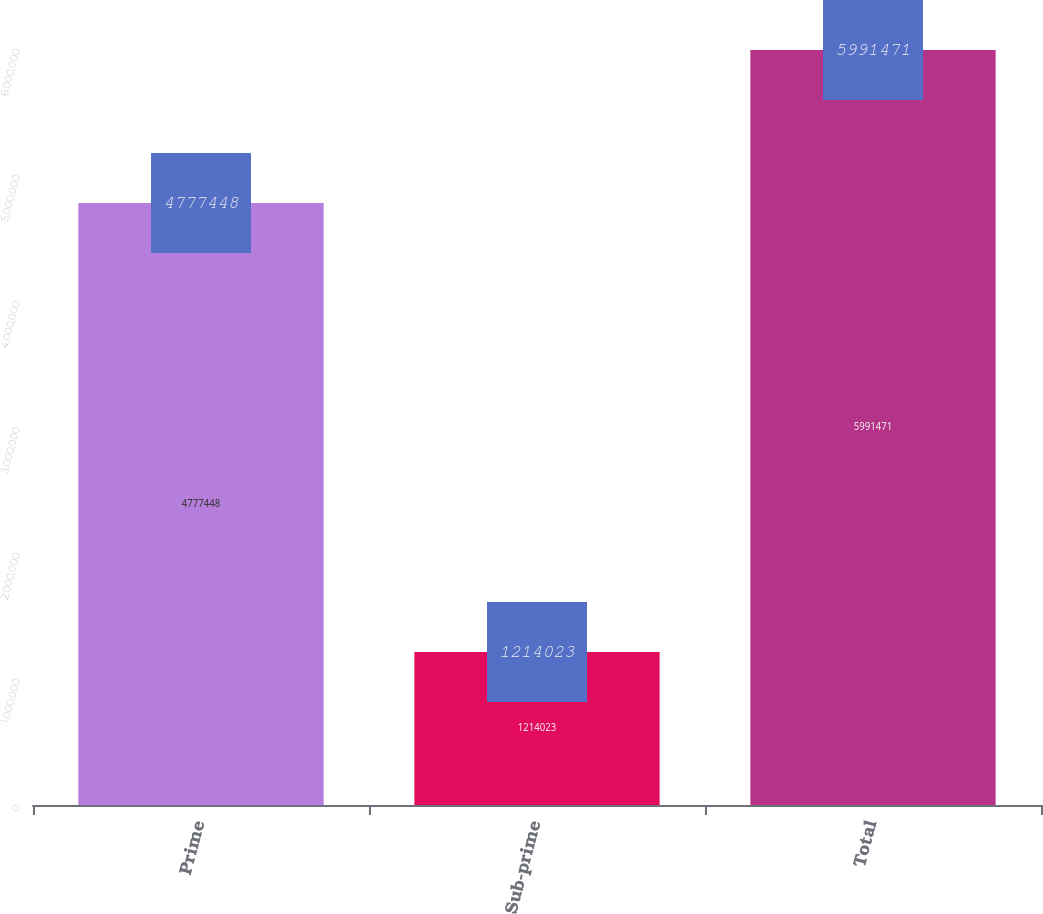Convert chart to OTSL. <chart><loc_0><loc_0><loc_500><loc_500><bar_chart><fcel>Prime<fcel>Sub-prime<fcel>Total<nl><fcel>4.77745e+06<fcel>1.21402e+06<fcel>5.99147e+06<nl></chart> 